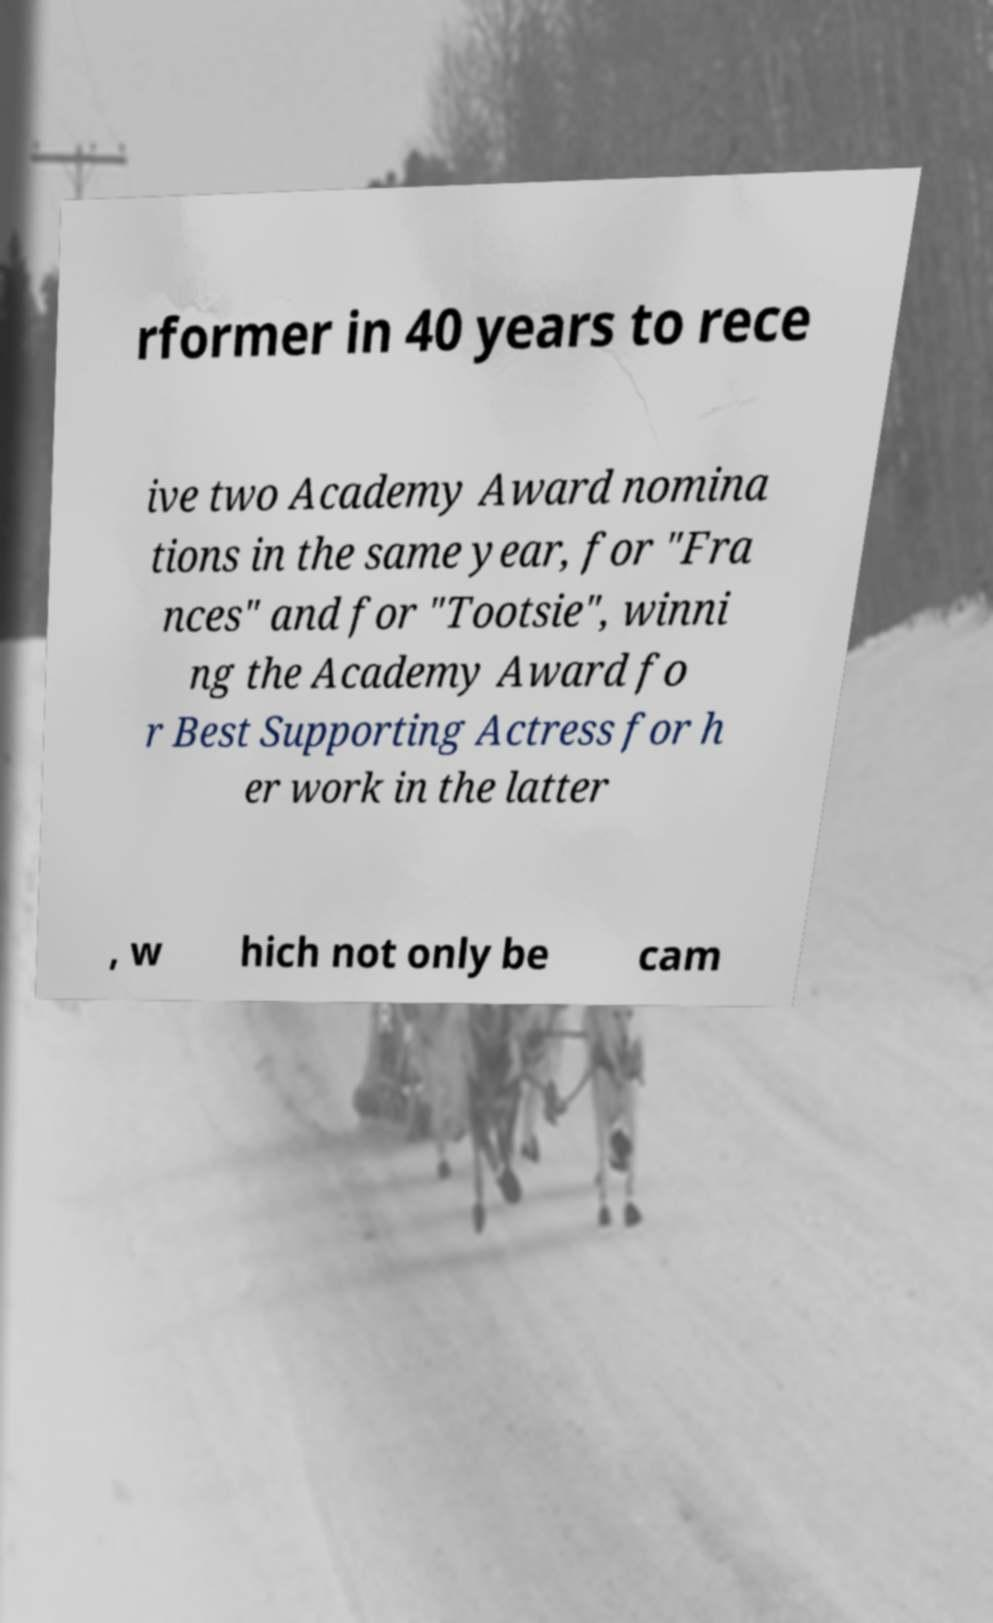Please read and relay the text visible in this image. What does it say? rformer in 40 years to rece ive two Academy Award nomina tions in the same year, for "Fra nces" and for "Tootsie", winni ng the Academy Award fo r Best Supporting Actress for h er work in the latter , w hich not only be cam 